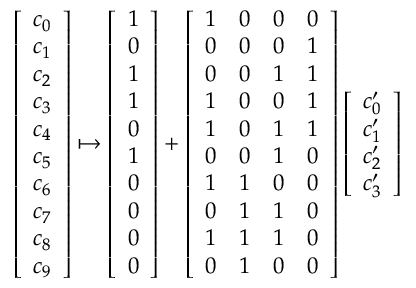Convert formula to latex. <formula><loc_0><loc_0><loc_500><loc_500>\begin{array} { r } { \left [ \begin{array} { l } { c _ { 0 } } \\ { c _ { 1 } } \\ { c _ { 2 } } \\ { c _ { 3 } } \\ { c _ { 4 } } \\ { c _ { 5 } } \\ { c _ { 6 } } \\ { c _ { 7 } } \\ { c _ { 8 } } \\ { c _ { 9 } } \end{array} \right ] \mapsto \left [ \begin{array} { l } { 1 } \\ { 0 } \\ { 1 } \\ { 1 } \\ { 0 } \\ { 1 } \\ { 0 } \\ { 0 } \\ { 0 } \\ { 0 } \end{array} \right ] + \left [ \begin{array} { l l l l } { 1 } & { 0 } & { 0 } & { 0 } \\ { 0 } & { 0 } & { 0 } & { 1 } \\ { 0 } & { 0 } & { 1 } & { 1 } \\ { 1 } & { 0 } & { 0 } & { 1 } \\ { 1 } & { 0 } & { 1 } & { 1 } \\ { 0 } & { 0 } & { 1 } & { 0 } \\ { 1 } & { 1 } & { 0 } & { 0 } \\ { 0 } & { 1 } & { 1 } & { 0 } \\ { 1 } & { 1 } & { 1 } & { 0 } \\ { 0 } & { 1 } & { 0 } & { 0 } \end{array} \right ] \left [ \begin{array} { l } { c _ { 0 } ^ { \prime } } \\ { c _ { 1 } ^ { \prime } } \\ { c _ { 2 } ^ { \prime } } \\ { c _ { 3 } ^ { \prime } } \end{array} \right ] } \end{array}</formula> 